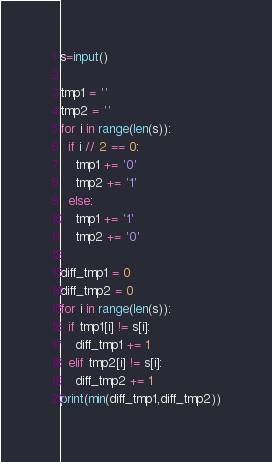Convert code to text. <code><loc_0><loc_0><loc_500><loc_500><_Python_>s=input()

tmp1 = ''
tmp2 = ''
for i in range(len(s)):
  if i // 2 == 0:
    tmp1 += '0'
    tmp2 += '1'
  else:
    tmp1 += '1'
    tmp2 += '0'
    
diff_tmp1 = 0
diff_tmp2 = 0
for i in range(len(s)):
  if tmp1[i] != s[i]:
    diff_tmp1 += 1
  elif tmp2[i] != s[i]:
    diff_tmp2 += 1
print(min(diff_tmp1,diff_tmp2))</code> 